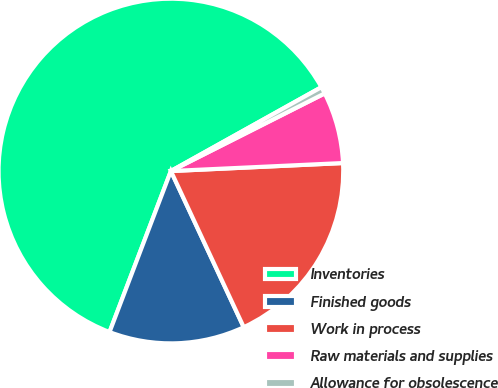Convert chart. <chart><loc_0><loc_0><loc_500><loc_500><pie_chart><fcel>Inventories<fcel>Finished goods<fcel>Work in process<fcel>Raw materials and supplies<fcel>Allowance for obsolescence<nl><fcel>61.11%<fcel>12.74%<fcel>18.79%<fcel>6.7%<fcel>0.65%<nl></chart> 